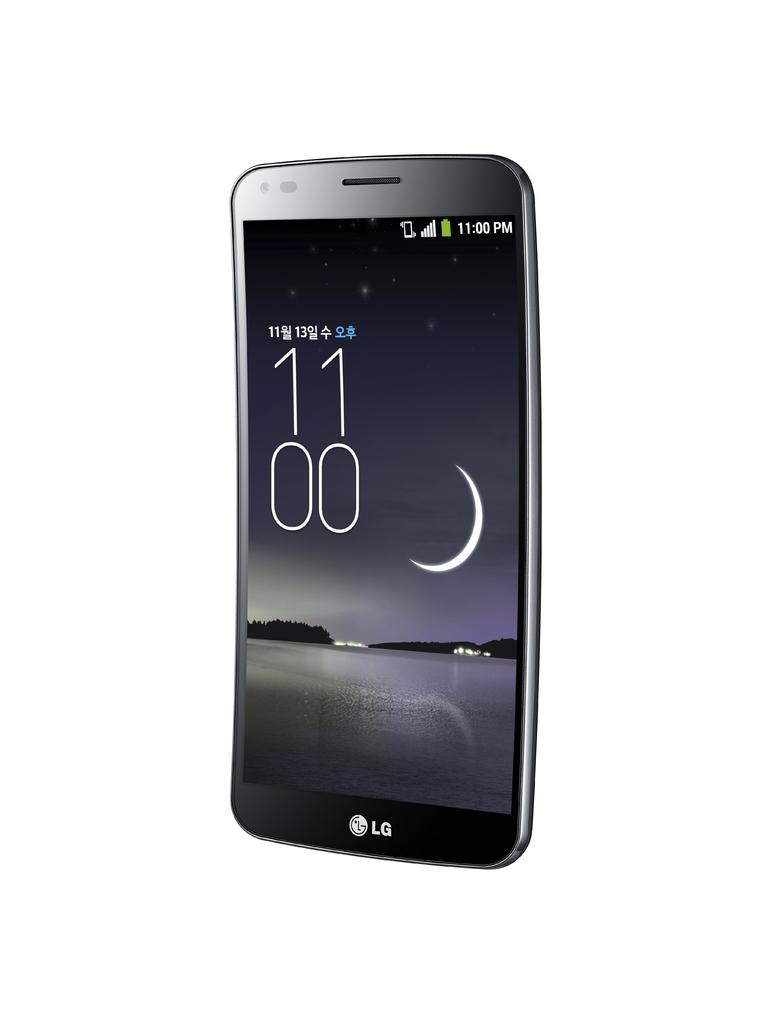<image>
Present a compact description of the photo's key features. a phone that has the time of 1100 on it 